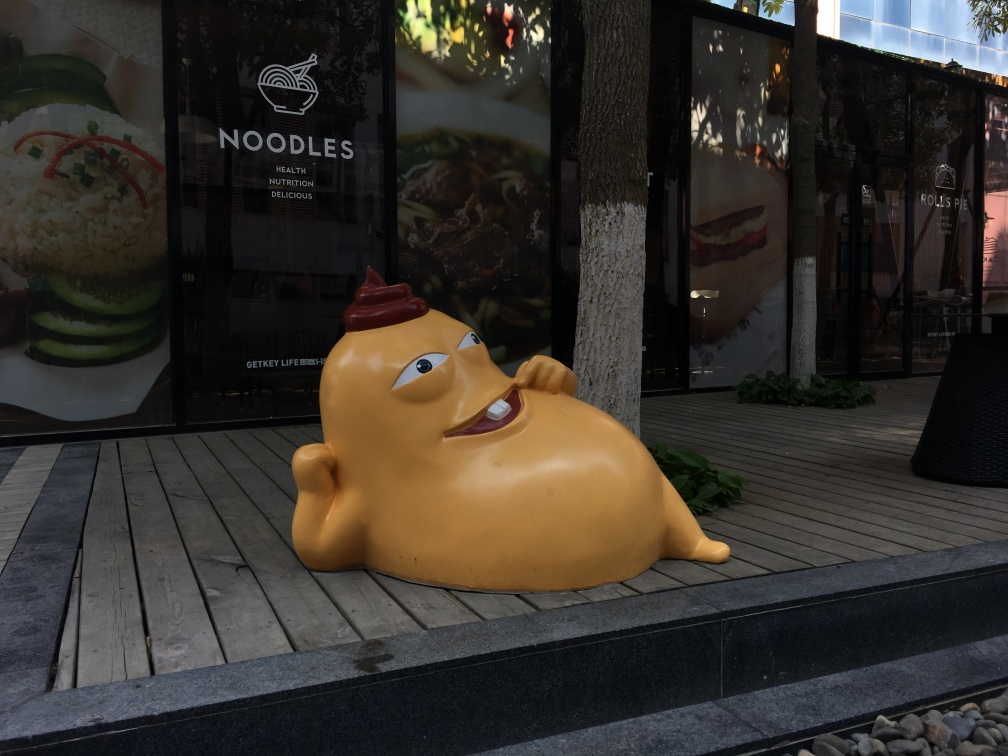Is the texture of the overall environment blurry? No, the texture of the overall environment is not blurry. The details of the scene, such as the wood planks on the deck, the leaves of the plants, and the posters on the glass wall are quite sharp and clear. 